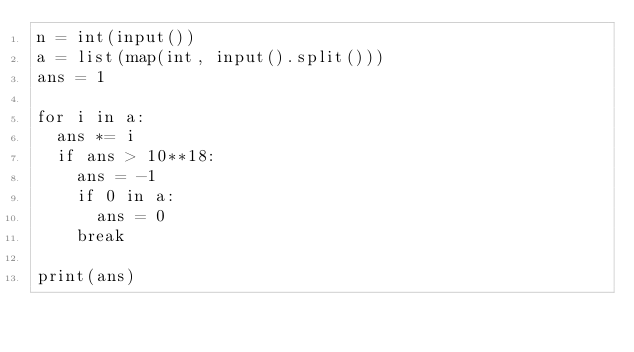<code> <loc_0><loc_0><loc_500><loc_500><_Python_>n = int(input())
a = list(map(int, input().split()))
ans = 1

for i in a:
	ans *= i
	if ans > 10**18:
		ans = -1
		if 0 in a:
			ans = 0
		break

print(ans)</code> 